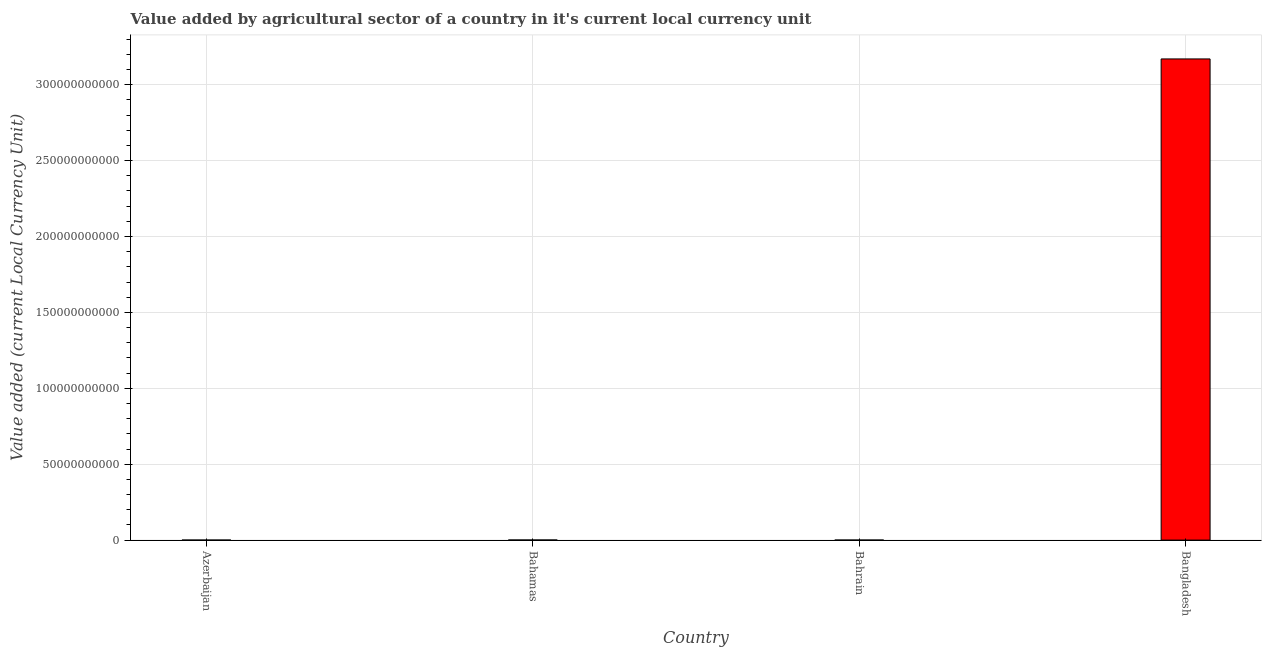Does the graph contain any zero values?
Keep it short and to the point. No. Does the graph contain grids?
Give a very brief answer. Yes. What is the title of the graph?
Offer a very short reply. Value added by agricultural sector of a country in it's current local currency unit. What is the label or title of the X-axis?
Offer a very short reply. Country. What is the label or title of the Y-axis?
Ensure brevity in your answer.  Value added (current Local Currency Unit). What is the value added by agriculture sector in Bangladesh?
Keep it short and to the point. 3.17e+11. Across all countries, what is the maximum value added by agriculture sector?
Provide a succinct answer. 3.17e+11. Across all countries, what is the minimum value added by agriculture sector?
Ensure brevity in your answer.  8.51e+06. In which country was the value added by agriculture sector maximum?
Offer a very short reply. Bangladesh. In which country was the value added by agriculture sector minimum?
Keep it short and to the point. Azerbaijan. What is the sum of the value added by agriculture sector?
Provide a short and direct response. 3.17e+11. What is the difference between the value added by agriculture sector in Azerbaijan and Bangladesh?
Your answer should be compact. -3.17e+11. What is the average value added by agriculture sector per country?
Offer a very short reply. 7.93e+1. What is the median value added by agriculture sector?
Give a very brief answer. 4.64e+07. What is the difference between the highest and the second highest value added by agriculture sector?
Your answer should be very brief. 3.17e+11. Is the sum of the value added by agriculture sector in Bahrain and Bangladesh greater than the maximum value added by agriculture sector across all countries?
Offer a terse response. Yes. What is the difference between the highest and the lowest value added by agriculture sector?
Provide a succinct answer. 3.17e+11. How many bars are there?
Your answer should be compact. 4. How many countries are there in the graph?
Your answer should be compact. 4. What is the difference between two consecutive major ticks on the Y-axis?
Offer a terse response. 5.00e+1. What is the Value added (current Local Currency Unit) of Azerbaijan?
Ensure brevity in your answer.  8.51e+06. What is the Value added (current Local Currency Unit) of Bahamas?
Ensure brevity in your answer.  7.61e+07. What is the Value added (current Local Currency Unit) in Bahrain?
Give a very brief answer. 1.66e+07. What is the Value added (current Local Currency Unit) in Bangladesh?
Provide a short and direct response. 3.17e+11. What is the difference between the Value added (current Local Currency Unit) in Azerbaijan and Bahamas?
Your answer should be very brief. -6.76e+07. What is the difference between the Value added (current Local Currency Unit) in Azerbaijan and Bahrain?
Offer a terse response. -8.13e+06. What is the difference between the Value added (current Local Currency Unit) in Azerbaijan and Bangladesh?
Your answer should be compact. -3.17e+11. What is the difference between the Value added (current Local Currency Unit) in Bahamas and Bahrain?
Keep it short and to the point. 5.95e+07. What is the difference between the Value added (current Local Currency Unit) in Bahamas and Bangladesh?
Make the answer very short. -3.17e+11. What is the difference between the Value added (current Local Currency Unit) in Bahrain and Bangladesh?
Provide a short and direct response. -3.17e+11. What is the ratio of the Value added (current Local Currency Unit) in Azerbaijan to that in Bahamas?
Keep it short and to the point. 0.11. What is the ratio of the Value added (current Local Currency Unit) in Azerbaijan to that in Bahrain?
Your answer should be compact. 0.51. What is the ratio of the Value added (current Local Currency Unit) in Azerbaijan to that in Bangladesh?
Your answer should be compact. 0. What is the ratio of the Value added (current Local Currency Unit) in Bahamas to that in Bahrain?
Your answer should be very brief. 4.57. 